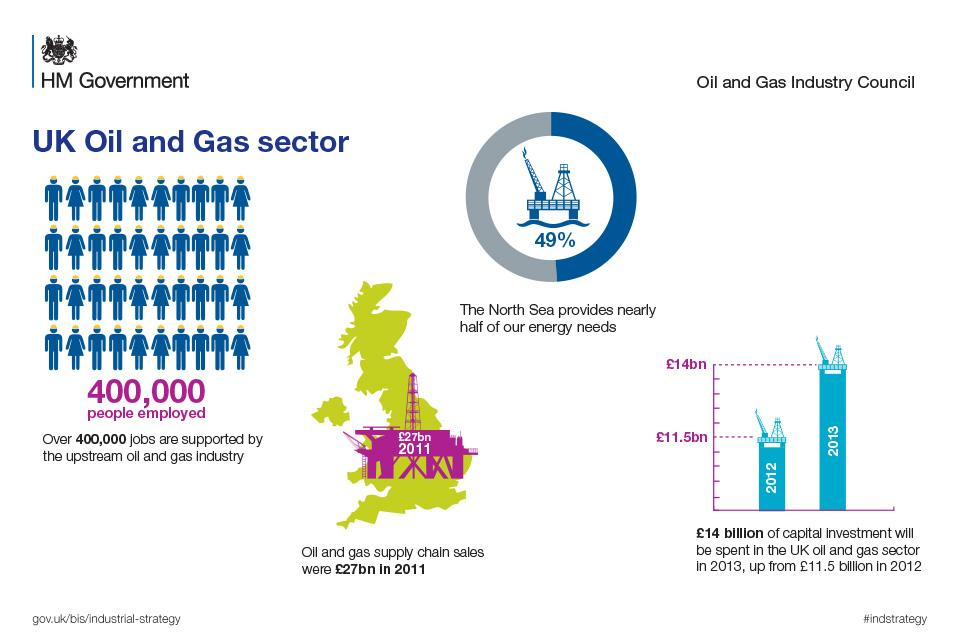Highlight a few significant elements in this photo. In 2012, the oil and gas sector saw a capital investment of approximately 11.5 billion pounds. The contribution of the North Sea to energy needs is exacted at 49%. 